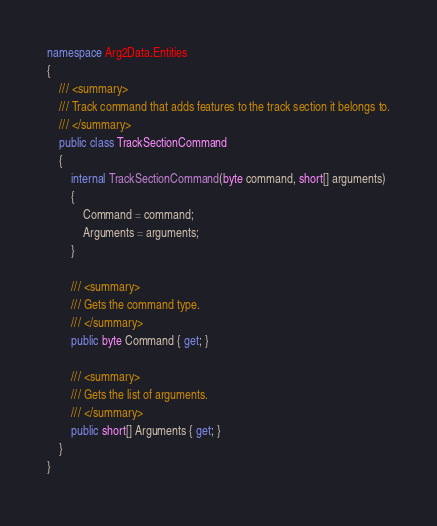<code> <loc_0><loc_0><loc_500><loc_500><_C#_>namespace Arg2Data.Entities
{
    /// <summary>
    /// Track command that adds features to the track section it belongs to.
    /// </summary>
    public class TrackSectionCommand
    {
        internal TrackSectionCommand(byte command, short[] arguments)
        {
            Command = command;
            Arguments = arguments;
        }

        /// <summary>
        /// Gets the command type.
        /// </summary>
        public byte Command { get; }

        /// <summary>
        /// Gets the list of arguments.
        /// </summary>
        public short[] Arguments { get; }
    }
}
</code> 